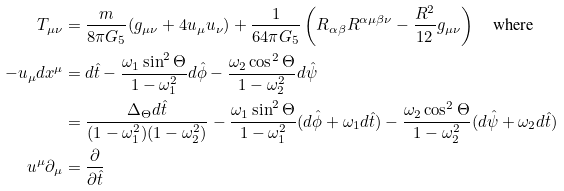<formula> <loc_0><loc_0><loc_500><loc_500>T _ { \mu \nu } & = \frac { m } { 8 \pi G _ { 5 } } ( g _ { \mu \nu } + 4 u _ { \mu } u _ { \nu } ) + \frac { 1 } { 6 4 \pi G _ { 5 } } \left ( R _ { \alpha \beta } R ^ { \alpha \mu \beta \nu } - \frac { R ^ { 2 } } { 1 2 } g _ { \mu \nu } \right ) \quad \text {where} \\ - u _ { \mu } d x ^ { \mu } & = d \hat { t } - \frac { \omega _ { 1 } \sin ^ { 2 } \Theta } { 1 - \omega _ { 1 } ^ { 2 } } d \hat { \phi } - \frac { \omega _ { 2 } \cos ^ { 2 } \Theta } { 1 - \omega _ { 2 } ^ { 2 } } d \hat { \psi } \\ & = \frac { \Delta _ { \Theta } d \hat { t } } { ( 1 - \omega _ { 1 } ^ { 2 } ) ( 1 - \omega _ { 2 } ^ { 2 } ) } - \frac { \omega _ { 1 } \sin ^ { 2 } \Theta } { 1 - \omega _ { 1 } ^ { 2 } } ( d \hat { \phi } + \omega _ { 1 } d \hat { t } ) - \frac { \omega _ { 2 } \cos ^ { 2 } \Theta } { 1 - \omega _ { 2 } ^ { 2 } } ( d \hat { \psi } + \omega _ { 2 } d \hat { t } ) \\ u ^ { \mu } \partial _ { \mu } & = \frac { \partial } { \partial \hat { t } }</formula> 